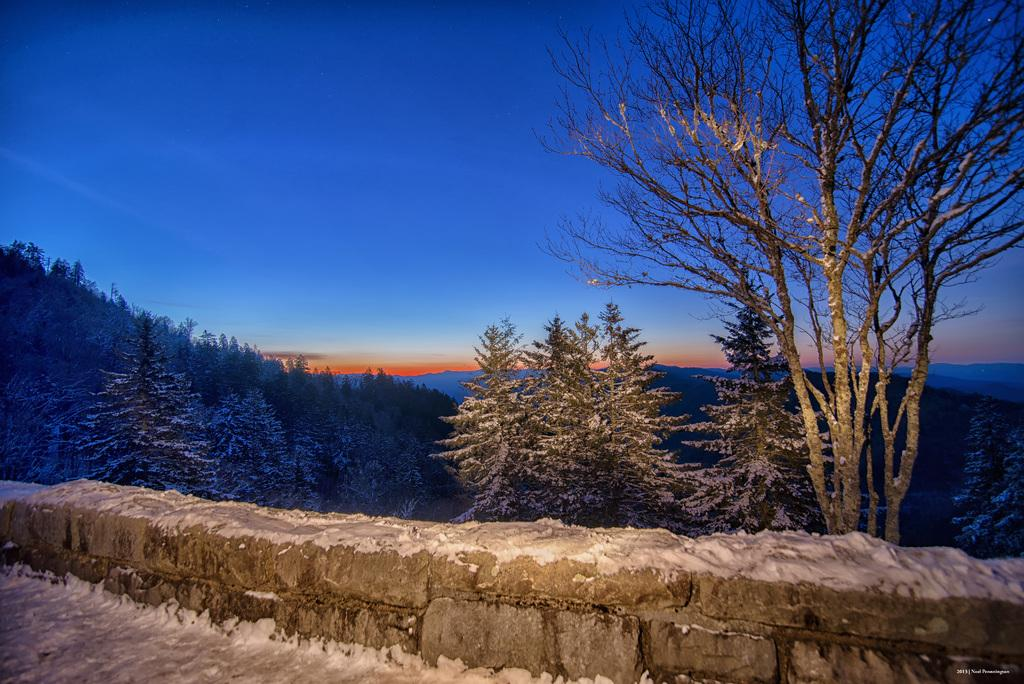What type of structure is present in the image? There is a wall in the image. What type of vegetation can be seen in the image? There are trees in the image. What can be seen in the background of the image? The sky is visible in the background of the image. What type of humor can be found in the powder on the wall in the image? There is no humor or powder present in the image; it only features a wall and trees with the sky visible in the background. 